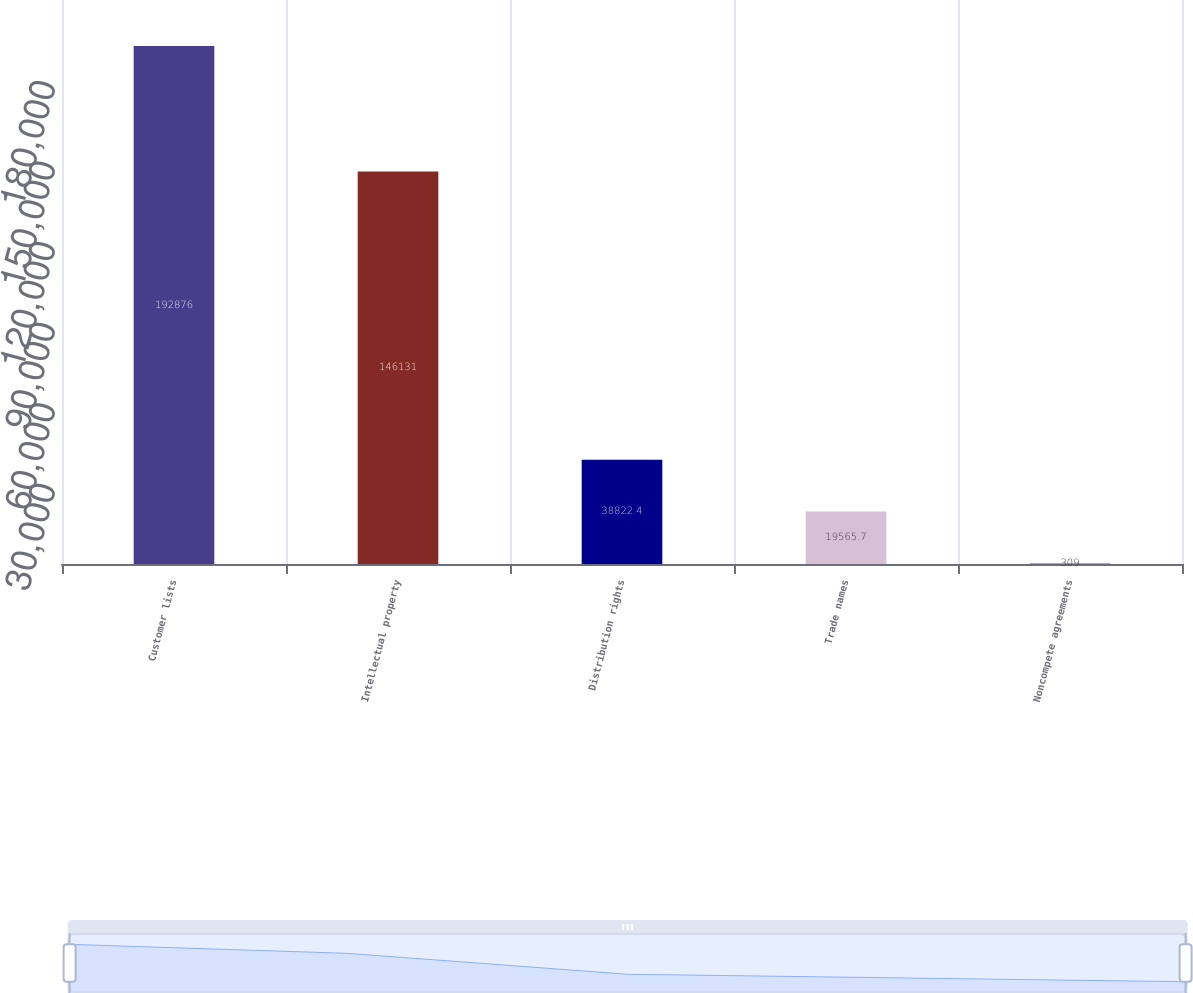<chart> <loc_0><loc_0><loc_500><loc_500><bar_chart><fcel>Customer lists<fcel>Intellectual property<fcel>Distribution rights<fcel>Trade names<fcel>Noncompete agreements<nl><fcel>192876<fcel>146131<fcel>38822.4<fcel>19565.7<fcel>309<nl></chart> 